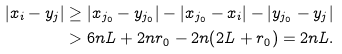Convert formula to latex. <formula><loc_0><loc_0><loc_500><loc_500>| x _ { i } - y _ { j } | & \geq | x _ { j _ { 0 } } - y _ { j _ { 0 } } | - | x _ { j _ { 0 } } - x _ { i } | - | y _ { j _ { 0 } } - y _ { j } | \\ & > 6 n L + 2 n r _ { 0 } - 2 n ( 2 L + r _ { 0 } ) = 2 n L .</formula> 